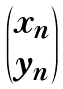Convert formula to latex. <formula><loc_0><loc_0><loc_500><loc_500>\begin{pmatrix} x _ { n } \\ y _ { n } \end{pmatrix}</formula> 